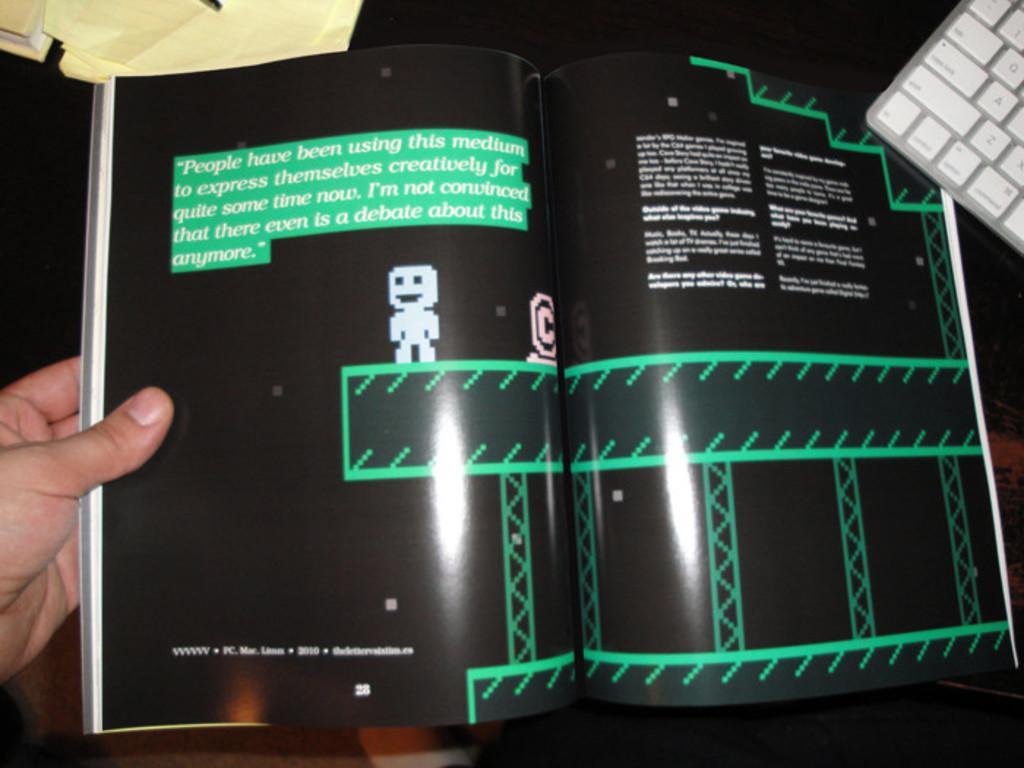Could you give a brief overview of what you see in this image? In this image, we can see a person holding a book and there is some text and we can see cartoon images. In the background, there is a keyboard and we can see some papers. 